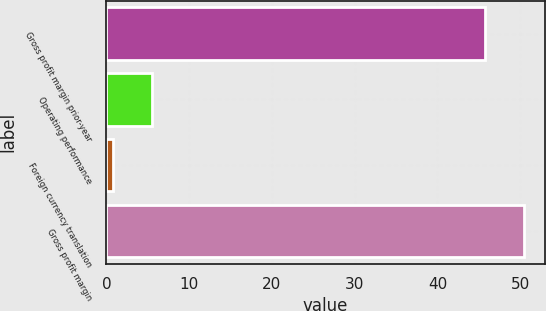Convert chart. <chart><loc_0><loc_0><loc_500><loc_500><bar_chart><fcel>Gross profit margin prior-year<fcel>Operating performance<fcel>Foreign currency translation<fcel>Gross profit margin<nl><fcel>45.7<fcel>5.52<fcel>0.8<fcel>50.42<nl></chart> 